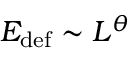Convert formula to latex. <formula><loc_0><loc_0><loc_500><loc_500>E _ { d e f } \sim L ^ { \theta }</formula> 